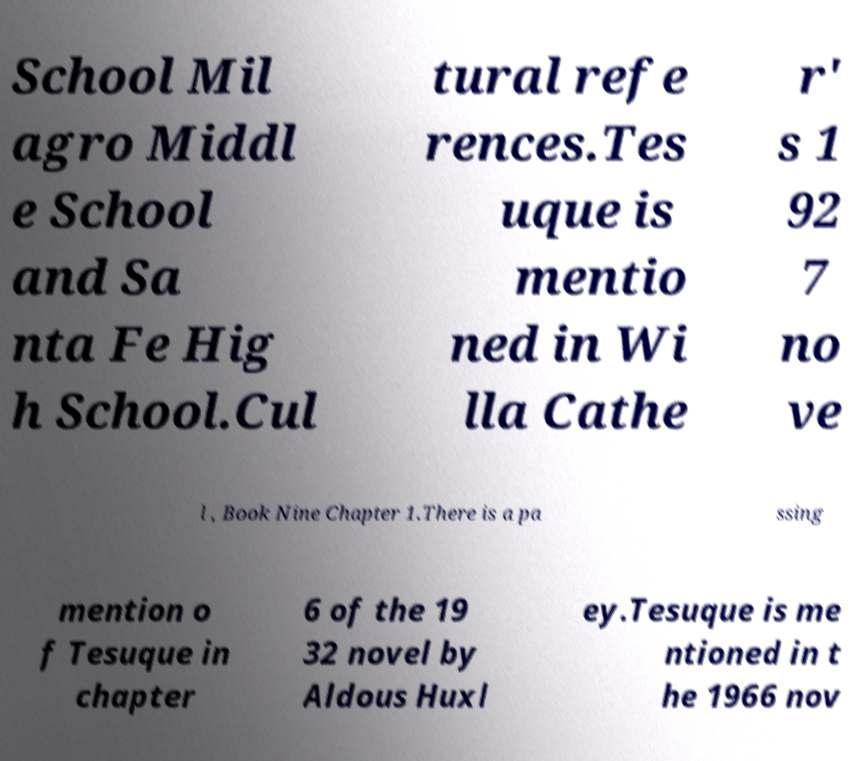Can you accurately transcribe the text from the provided image for me? School Mil agro Middl e School and Sa nta Fe Hig h School.Cul tural refe rences.Tes uque is mentio ned in Wi lla Cathe r' s 1 92 7 no ve l , Book Nine Chapter 1.There is a pa ssing mention o f Tesuque in chapter 6 of the 19 32 novel by Aldous Huxl ey.Tesuque is me ntioned in t he 1966 nov 